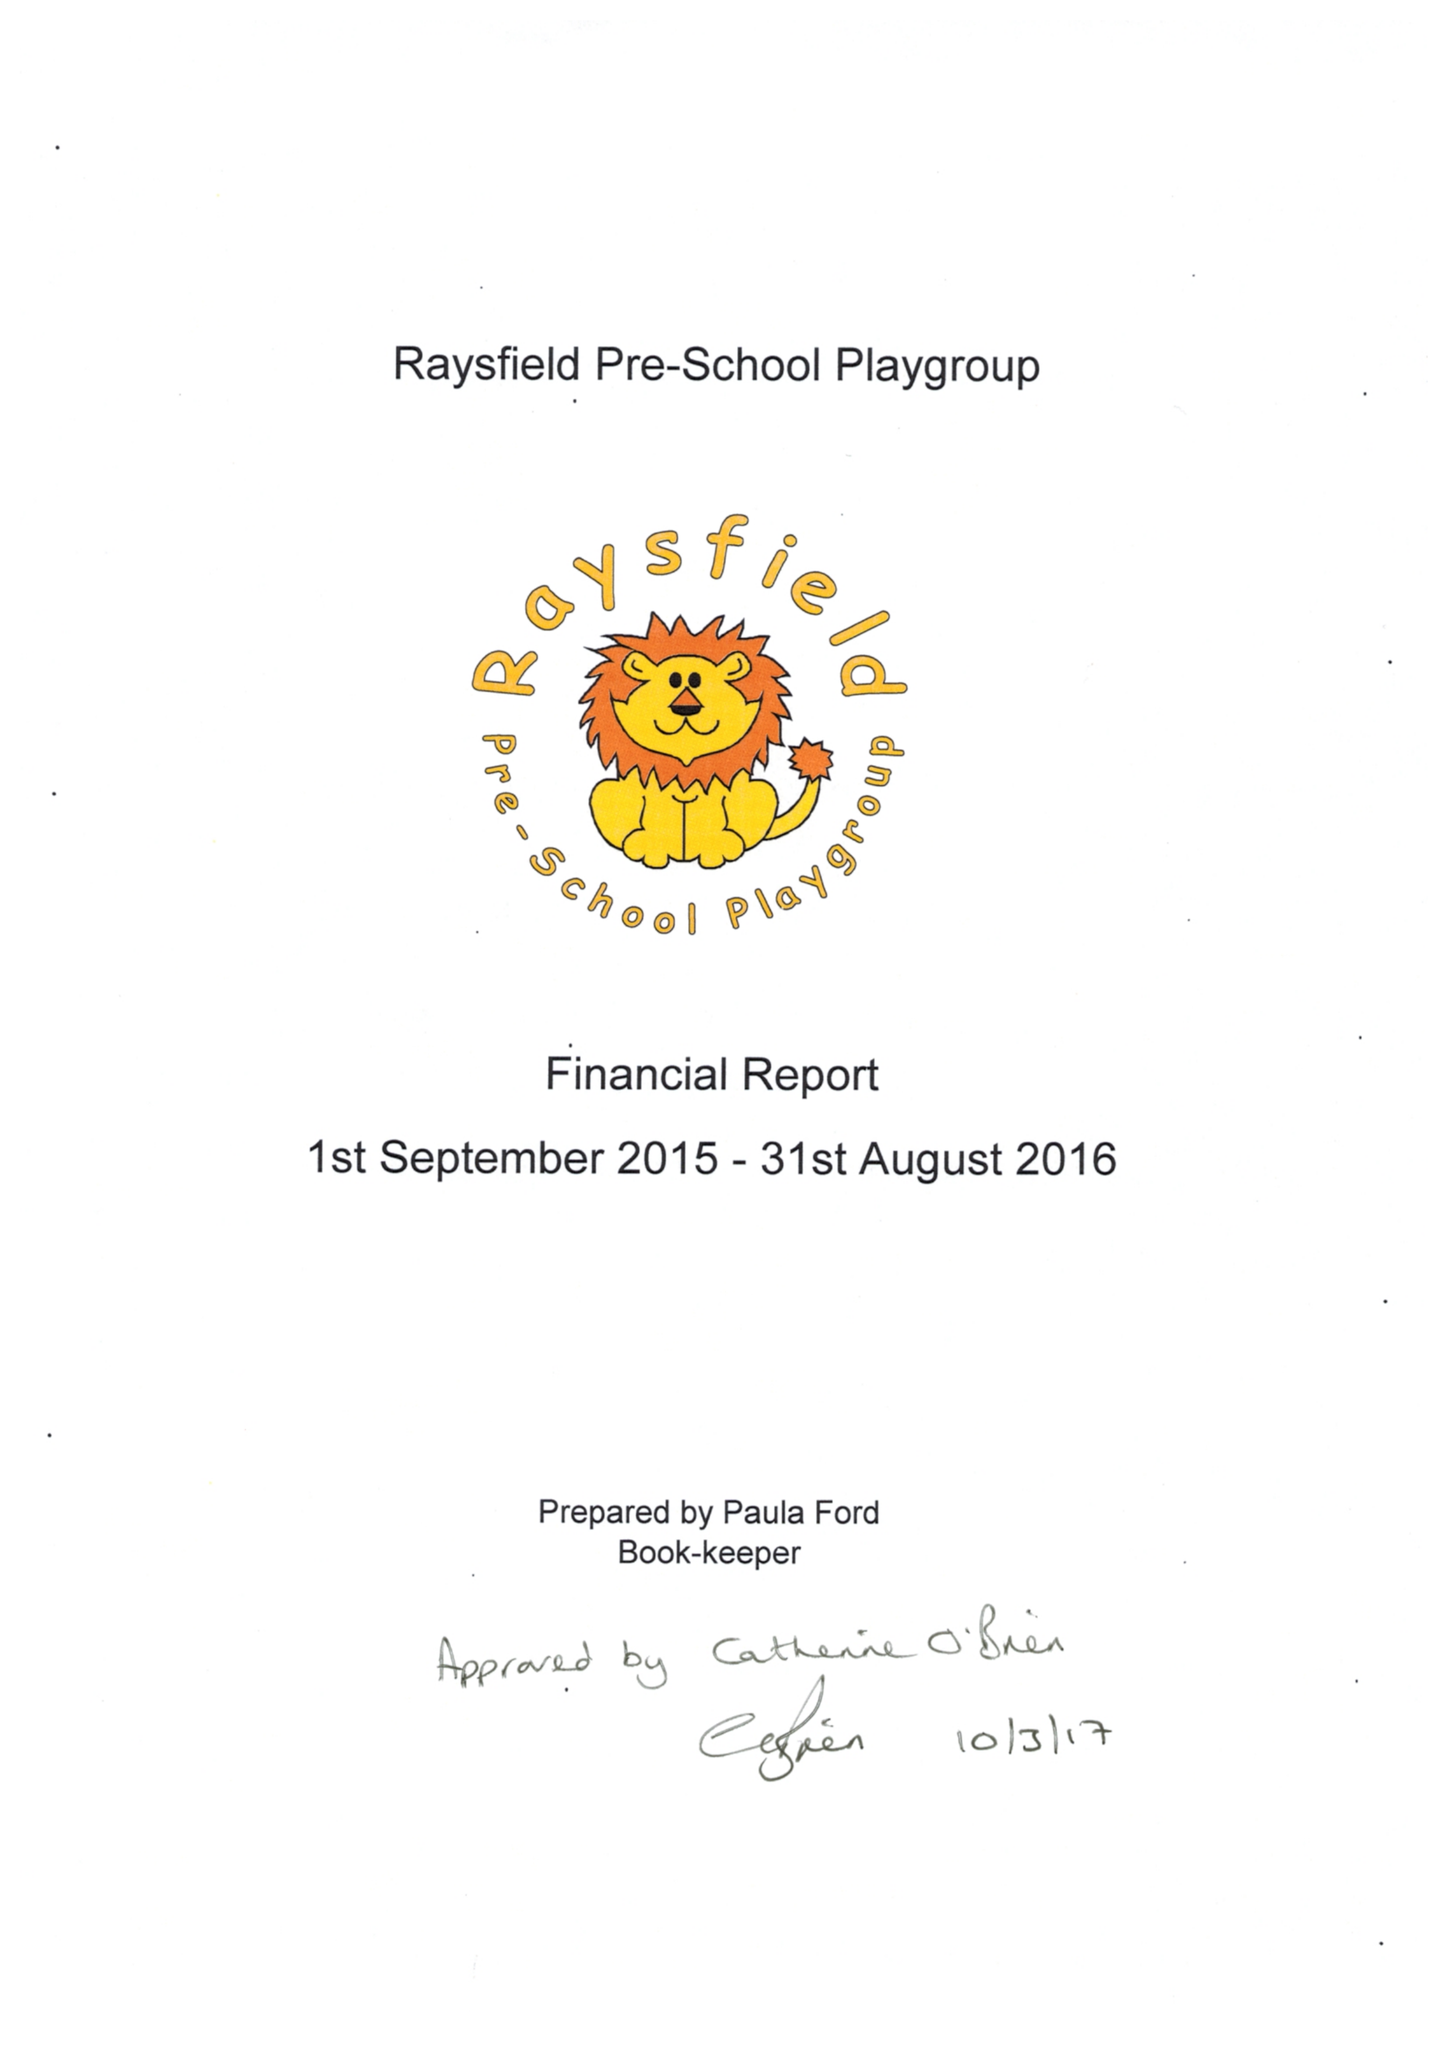What is the value for the spending_annually_in_british_pounds?
Answer the question using a single word or phrase. 94257.00 